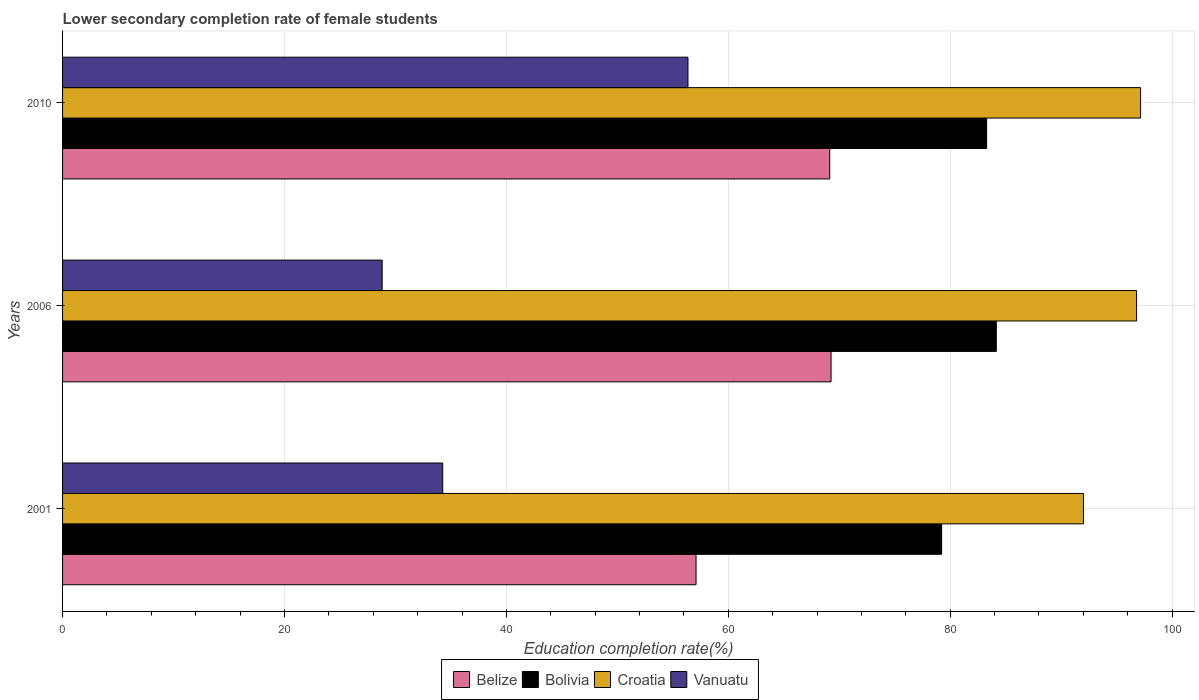Are the number of bars per tick equal to the number of legend labels?
Your answer should be very brief. Yes. How many bars are there on the 3rd tick from the top?
Provide a succinct answer. 4. What is the lower secondary completion rate of female students in Bolivia in 2010?
Offer a terse response. 83.28. Across all years, what is the maximum lower secondary completion rate of female students in Bolivia?
Your answer should be very brief. 84.15. Across all years, what is the minimum lower secondary completion rate of female students in Croatia?
Offer a very short reply. 92.01. What is the total lower secondary completion rate of female students in Croatia in the graph?
Keep it short and to the point. 285.96. What is the difference between the lower secondary completion rate of female students in Vanuatu in 2001 and that in 2006?
Ensure brevity in your answer.  5.46. What is the difference between the lower secondary completion rate of female students in Bolivia in 2006 and the lower secondary completion rate of female students in Belize in 2010?
Your response must be concise. 15.02. What is the average lower secondary completion rate of female students in Bolivia per year?
Give a very brief answer. 82.22. In the year 2001, what is the difference between the lower secondary completion rate of female students in Belize and lower secondary completion rate of female students in Vanuatu?
Offer a terse response. 22.83. What is the ratio of the lower secondary completion rate of female students in Croatia in 2001 to that in 2006?
Give a very brief answer. 0.95. Is the difference between the lower secondary completion rate of female students in Belize in 2001 and 2006 greater than the difference between the lower secondary completion rate of female students in Vanuatu in 2001 and 2006?
Provide a short and direct response. No. What is the difference between the highest and the second highest lower secondary completion rate of female students in Vanuatu?
Provide a succinct answer. 22.1. What is the difference between the highest and the lowest lower secondary completion rate of female students in Vanuatu?
Provide a succinct answer. 27.56. In how many years, is the lower secondary completion rate of female students in Vanuatu greater than the average lower secondary completion rate of female students in Vanuatu taken over all years?
Offer a very short reply. 1. Is it the case that in every year, the sum of the lower secondary completion rate of female students in Vanuatu and lower secondary completion rate of female students in Bolivia is greater than the sum of lower secondary completion rate of female students in Croatia and lower secondary completion rate of female students in Belize?
Ensure brevity in your answer.  Yes. What does the 4th bar from the top in 2010 represents?
Offer a terse response. Belize. Is it the case that in every year, the sum of the lower secondary completion rate of female students in Vanuatu and lower secondary completion rate of female students in Croatia is greater than the lower secondary completion rate of female students in Bolivia?
Keep it short and to the point. Yes. Are all the bars in the graph horizontal?
Provide a succinct answer. Yes. Are the values on the major ticks of X-axis written in scientific E-notation?
Make the answer very short. No. Does the graph contain any zero values?
Your response must be concise. No. Where does the legend appear in the graph?
Offer a terse response. Bottom center. How many legend labels are there?
Your answer should be compact. 4. How are the legend labels stacked?
Give a very brief answer. Horizontal. What is the title of the graph?
Ensure brevity in your answer.  Lower secondary completion rate of female students. Does "El Salvador" appear as one of the legend labels in the graph?
Make the answer very short. No. What is the label or title of the X-axis?
Keep it short and to the point. Education completion rate(%). What is the Education completion rate(%) in Belize in 2001?
Make the answer very short. 57.09. What is the Education completion rate(%) of Bolivia in 2001?
Provide a short and direct response. 79.23. What is the Education completion rate(%) in Croatia in 2001?
Provide a short and direct response. 92.01. What is the Education completion rate(%) in Vanuatu in 2001?
Offer a terse response. 34.26. What is the Education completion rate(%) in Belize in 2006?
Ensure brevity in your answer.  69.26. What is the Education completion rate(%) in Bolivia in 2006?
Provide a succinct answer. 84.15. What is the Education completion rate(%) in Croatia in 2006?
Your answer should be very brief. 96.8. What is the Education completion rate(%) in Vanuatu in 2006?
Ensure brevity in your answer.  28.8. What is the Education completion rate(%) of Belize in 2010?
Provide a short and direct response. 69.14. What is the Education completion rate(%) of Bolivia in 2010?
Provide a short and direct response. 83.28. What is the Education completion rate(%) in Croatia in 2010?
Provide a succinct answer. 97.16. What is the Education completion rate(%) in Vanuatu in 2010?
Keep it short and to the point. 56.36. Across all years, what is the maximum Education completion rate(%) in Belize?
Offer a very short reply. 69.26. Across all years, what is the maximum Education completion rate(%) in Bolivia?
Ensure brevity in your answer.  84.15. Across all years, what is the maximum Education completion rate(%) of Croatia?
Offer a terse response. 97.16. Across all years, what is the maximum Education completion rate(%) in Vanuatu?
Offer a terse response. 56.36. Across all years, what is the minimum Education completion rate(%) of Belize?
Make the answer very short. 57.09. Across all years, what is the minimum Education completion rate(%) of Bolivia?
Your response must be concise. 79.23. Across all years, what is the minimum Education completion rate(%) of Croatia?
Keep it short and to the point. 92.01. Across all years, what is the minimum Education completion rate(%) of Vanuatu?
Provide a succinct answer. 28.8. What is the total Education completion rate(%) of Belize in the graph?
Provide a short and direct response. 195.49. What is the total Education completion rate(%) in Bolivia in the graph?
Make the answer very short. 246.66. What is the total Education completion rate(%) in Croatia in the graph?
Provide a short and direct response. 285.96. What is the total Education completion rate(%) of Vanuatu in the graph?
Your answer should be very brief. 119.43. What is the difference between the Education completion rate(%) of Belize in 2001 and that in 2006?
Keep it short and to the point. -12.17. What is the difference between the Education completion rate(%) in Bolivia in 2001 and that in 2006?
Your answer should be compact. -4.93. What is the difference between the Education completion rate(%) in Croatia in 2001 and that in 2006?
Offer a terse response. -4.78. What is the difference between the Education completion rate(%) of Vanuatu in 2001 and that in 2006?
Ensure brevity in your answer.  5.46. What is the difference between the Education completion rate(%) in Belize in 2001 and that in 2010?
Keep it short and to the point. -12.05. What is the difference between the Education completion rate(%) of Bolivia in 2001 and that in 2010?
Provide a short and direct response. -4.05. What is the difference between the Education completion rate(%) in Croatia in 2001 and that in 2010?
Make the answer very short. -5.15. What is the difference between the Education completion rate(%) in Vanuatu in 2001 and that in 2010?
Give a very brief answer. -22.1. What is the difference between the Education completion rate(%) in Belize in 2006 and that in 2010?
Offer a terse response. 0.12. What is the difference between the Education completion rate(%) of Bolivia in 2006 and that in 2010?
Your answer should be compact. 0.87. What is the difference between the Education completion rate(%) in Croatia in 2006 and that in 2010?
Ensure brevity in your answer.  -0.36. What is the difference between the Education completion rate(%) of Vanuatu in 2006 and that in 2010?
Offer a terse response. -27.56. What is the difference between the Education completion rate(%) in Belize in 2001 and the Education completion rate(%) in Bolivia in 2006?
Provide a succinct answer. -27.06. What is the difference between the Education completion rate(%) in Belize in 2001 and the Education completion rate(%) in Croatia in 2006?
Ensure brevity in your answer.  -39.7. What is the difference between the Education completion rate(%) of Belize in 2001 and the Education completion rate(%) of Vanuatu in 2006?
Give a very brief answer. 28.29. What is the difference between the Education completion rate(%) in Bolivia in 2001 and the Education completion rate(%) in Croatia in 2006?
Provide a short and direct response. -17.57. What is the difference between the Education completion rate(%) of Bolivia in 2001 and the Education completion rate(%) of Vanuatu in 2006?
Keep it short and to the point. 50.42. What is the difference between the Education completion rate(%) of Croatia in 2001 and the Education completion rate(%) of Vanuatu in 2006?
Your answer should be compact. 63.21. What is the difference between the Education completion rate(%) of Belize in 2001 and the Education completion rate(%) of Bolivia in 2010?
Keep it short and to the point. -26.19. What is the difference between the Education completion rate(%) in Belize in 2001 and the Education completion rate(%) in Croatia in 2010?
Your answer should be very brief. -40.06. What is the difference between the Education completion rate(%) of Belize in 2001 and the Education completion rate(%) of Vanuatu in 2010?
Offer a terse response. 0.73. What is the difference between the Education completion rate(%) in Bolivia in 2001 and the Education completion rate(%) in Croatia in 2010?
Make the answer very short. -17.93. What is the difference between the Education completion rate(%) of Bolivia in 2001 and the Education completion rate(%) of Vanuatu in 2010?
Keep it short and to the point. 22.86. What is the difference between the Education completion rate(%) of Croatia in 2001 and the Education completion rate(%) of Vanuatu in 2010?
Offer a terse response. 35.65. What is the difference between the Education completion rate(%) of Belize in 2006 and the Education completion rate(%) of Bolivia in 2010?
Provide a short and direct response. -14.02. What is the difference between the Education completion rate(%) of Belize in 2006 and the Education completion rate(%) of Croatia in 2010?
Your response must be concise. -27.9. What is the difference between the Education completion rate(%) in Belize in 2006 and the Education completion rate(%) in Vanuatu in 2010?
Give a very brief answer. 12.9. What is the difference between the Education completion rate(%) in Bolivia in 2006 and the Education completion rate(%) in Croatia in 2010?
Your answer should be very brief. -13. What is the difference between the Education completion rate(%) of Bolivia in 2006 and the Education completion rate(%) of Vanuatu in 2010?
Offer a very short reply. 27.79. What is the difference between the Education completion rate(%) of Croatia in 2006 and the Education completion rate(%) of Vanuatu in 2010?
Ensure brevity in your answer.  40.43. What is the average Education completion rate(%) of Belize per year?
Your response must be concise. 65.16. What is the average Education completion rate(%) in Bolivia per year?
Make the answer very short. 82.22. What is the average Education completion rate(%) of Croatia per year?
Offer a terse response. 95.32. What is the average Education completion rate(%) in Vanuatu per year?
Provide a succinct answer. 39.81. In the year 2001, what is the difference between the Education completion rate(%) in Belize and Education completion rate(%) in Bolivia?
Give a very brief answer. -22.13. In the year 2001, what is the difference between the Education completion rate(%) of Belize and Education completion rate(%) of Croatia?
Ensure brevity in your answer.  -34.92. In the year 2001, what is the difference between the Education completion rate(%) in Belize and Education completion rate(%) in Vanuatu?
Your answer should be compact. 22.83. In the year 2001, what is the difference between the Education completion rate(%) in Bolivia and Education completion rate(%) in Croatia?
Keep it short and to the point. -12.78. In the year 2001, what is the difference between the Education completion rate(%) of Bolivia and Education completion rate(%) of Vanuatu?
Ensure brevity in your answer.  44.96. In the year 2001, what is the difference between the Education completion rate(%) of Croatia and Education completion rate(%) of Vanuatu?
Your answer should be very brief. 57.75. In the year 2006, what is the difference between the Education completion rate(%) in Belize and Education completion rate(%) in Bolivia?
Offer a terse response. -14.89. In the year 2006, what is the difference between the Education completion rate(%) in Belize and Education completion rate(%) in Croatia?
Provide a short and direct response. -27.53. In the year 2006, what is the difference between the Education completion rate(%) in Belize and Education completion rate(%) in Vanuatu?
Ensure brevity in your answer.  40.46. In the year 2006, what is the difference between the Education completion rate(%) in Bolivia and Education completion rate(%) in Croatia?
Make the answer very short. -12.64. In the year 2006, what is the difference between the Education completion rate(%) of Bolivia and Education completion rate(%) of Vanuatu?
Your answer should be very brief. 55.35. In the year 2006, what is the difference between the Education completion rate(%) of Croatia and Education completion rate(%) of Vanuatu?
Your response must be concise. 67.99. In the year 2010, what is the difference between the Education completion rate(%) of Belize and Education completion rate(%) of Bolivia?
Give a very brief answer. -14.14. In the year 2010, what is the difference between the Education completion rate(%) of Belize and Education completion rate(%) of Croatia?
Your response must be concise. -28.02. In the year 2010, what is the difference between the Education completion rate(%) in Belize and Education completion rate(%) in Vanuatu?
Give a very brief answer. 12.77. In the year 2010, what is the difference between the Education completion rate(%) in Bolivia and Education completion rate(%) in Croatia?
Ensure brevity in your answer.  -13.88. In the year 2010, what is the difference between the Education completion rate(%) of Bolivia and Education completion rate(%) of Vanuatu?
Your answer should be very brief. 26.92. In the year 2010, what is the difference between the Education completion rate(%) of Croatia and Education completion rate(%) of Vanuatu?
Provide a succinct answer. 40.79. What is the ratio of the Education completion rate(%) of Belize in 2001 to that in 2006?
Provide a succinct answer. 0.82. What is the ratio of the Education completion rate(%) in Bolivia in 2001 to that in 2006?
Your answer should be very brief. 0.94. What is the ratio of the Education completion rate(%) in Croatia in 2001 to that in 2006?
Make the answer very short. 0.95. What is the ratio of the Education completion rate(%) in Vanuatu in 2001 to that in 2006?
Your answer should be compact. 1.19. What is the ratio of the Education completion rate(%) in Belize in 2001 to that in 2010?
Ensure brevity in your answer.  0.83. What is the ratio of the Education completion rate(%) in Bolivia in 2001 to that in 2010?
Your response must be concise. 0.95. What is the ratio of the Education completion rate(%) in Croatia in 2001 to that in 2010?
Provide a short and direct response. 0.95. What is the ratio of the Education completion rate(%) of Vanuatu in 2001 to that in 2010?
Your response must be concise. 0.61. What is the ratio of the Education completion rate(%) of Bolivia in 2006 to that in 2010?
Your response must be concise. 1.01. What is the ratio of the Education completion rate(%) of Croatia in 2006 to that in 2010?
Provide a short and direct response. 1. What is the ratio of the Education completion rate(%) in Vanuatu in 2006 to that in 2010?
Your answer should be compact. 0.51. What is the difference between the highest and the second highest Education completion rate(%) of Belize?
Your answer should be compact. 0.12. What is the difference between the highest and the second highest Education completion rate(%) in Bolivia?
Give a very brief answer. 0.87. What is the difference between the highest and the second highest Education completion rate(%) in Croatia?
Offer a very short reply. 0.36. What is the difference between the highest and the second highest Education completion rate(%) of Vanuatu?
Provide a succinct answer. 22.1. What is the difference between the highest and the lowest Education completion rate(%) of Belize?
Give a very brief answer. 12.17. What is the difference between the highest and the lowest Education completion rate(%) in Bolivia?
Your answer should be very brief. 4.93. What is the difference between the highest and the lowest Education completion rate(%) of Croatia?
Offer a very short reply. 5.15. What is the difference between the highest and the lowest Education completion rate(%) of Vanuatu?
Provide a short and direct response. 27.56. 